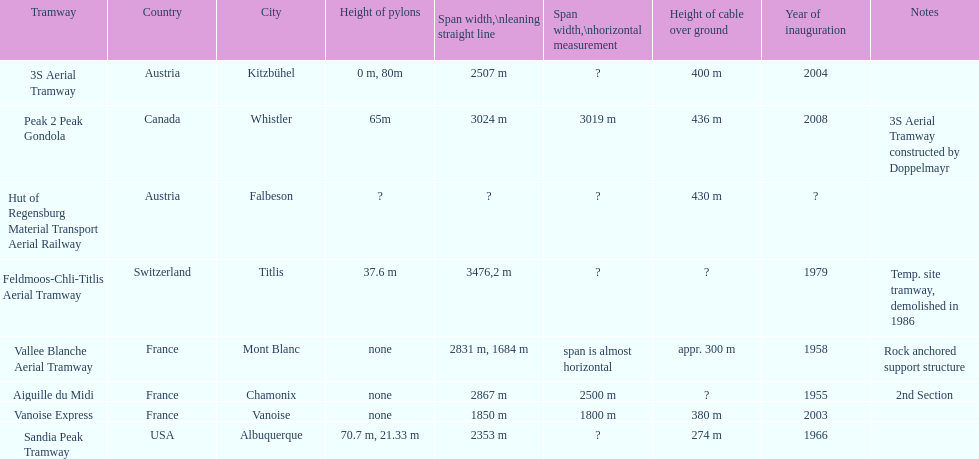How much longer is the peak 2 peak gondola than the 32 aerial tramway? 517. 